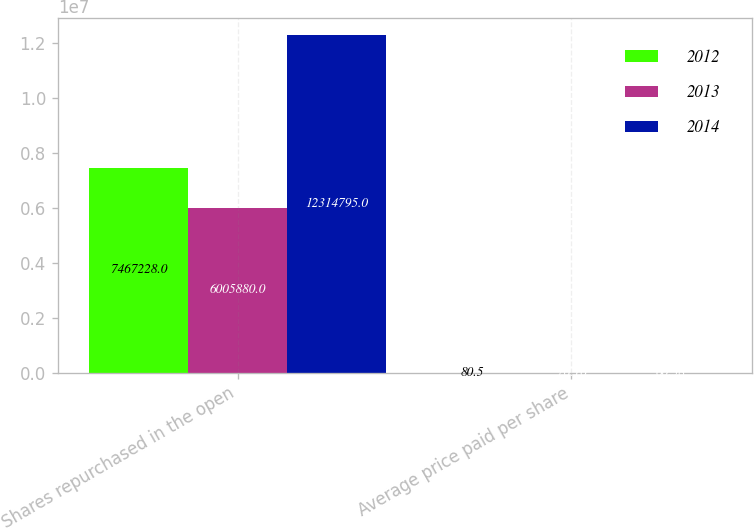Convert chart. <chart><loc_0><loc_0><loc_500><loc_500><stacked_bar_chart><ecel><fcel>Shares repurchased in the open<fcel>Average price paid per share<nl><fcel>2012<fcel>7.46723e+06<fcel>80.5<nl><fcel>2013<fcel>6.00588e+06<fcel>76.16<nl><fcel>2014<fcel>1.23148e+07<fcel>60.38<nl></chart> 